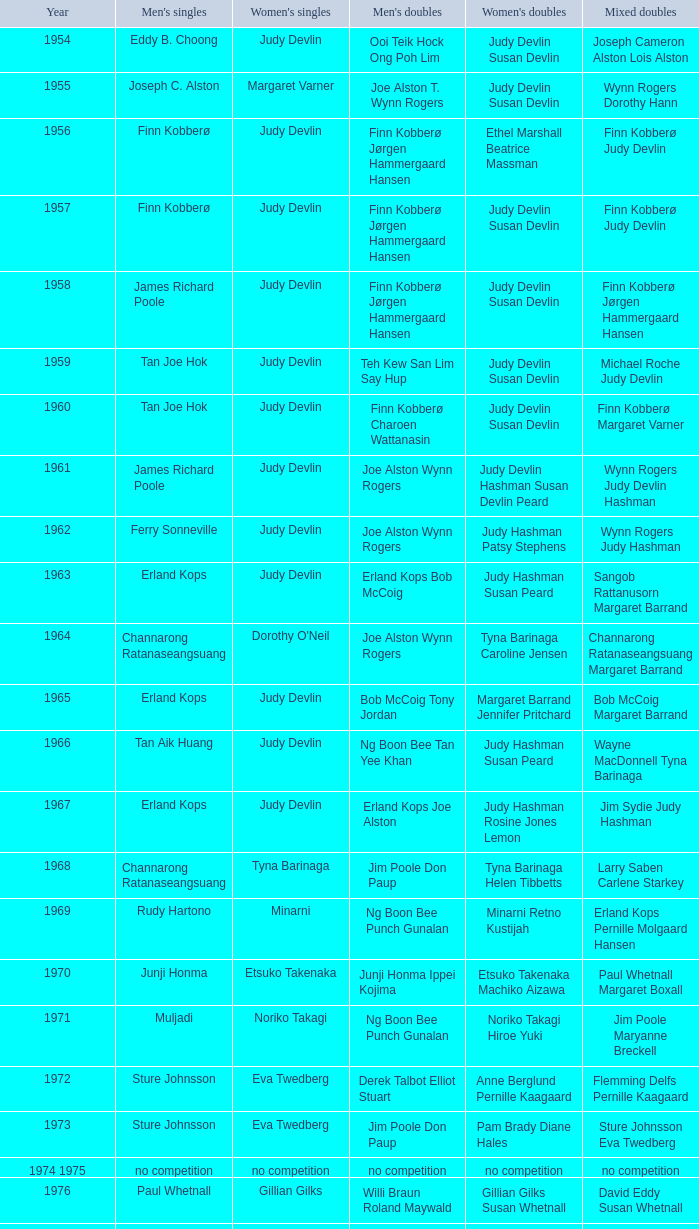Who was the women's singles champion in 1984? Luo Yun. 